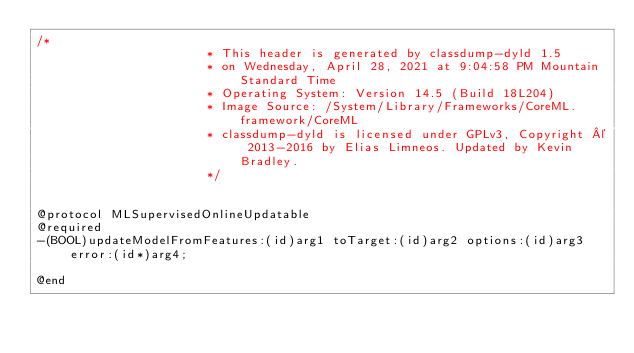Convert code to text. <code><loc_0><loc_0><loc_500><loc_500><_C_>/*
                       * This header is generated by classdump-dyld 1.5
                       * on Wednesday, April 28, 2021 at 9:04:58 PM Mountain Standard Time
                       * Operating System: Version 14.5 (Build 18L204)
                       * Image Source: /System/Library/Frameworks/CoreML.framework/CoreML
                       * classdump-dyld is licensed under GPLv3, Copyright © 2013-2016 by Elias Limneos. Updated by Kevin Bradley.
                       */


@protocol MLSupervisedOnlineUpdatable
@required
-(BOOL)updateModelFromFeatures:(id)arg1 toTarget:(id)arg2 options:(id)arg3 error:(id*)arg4;

@end

</code> 